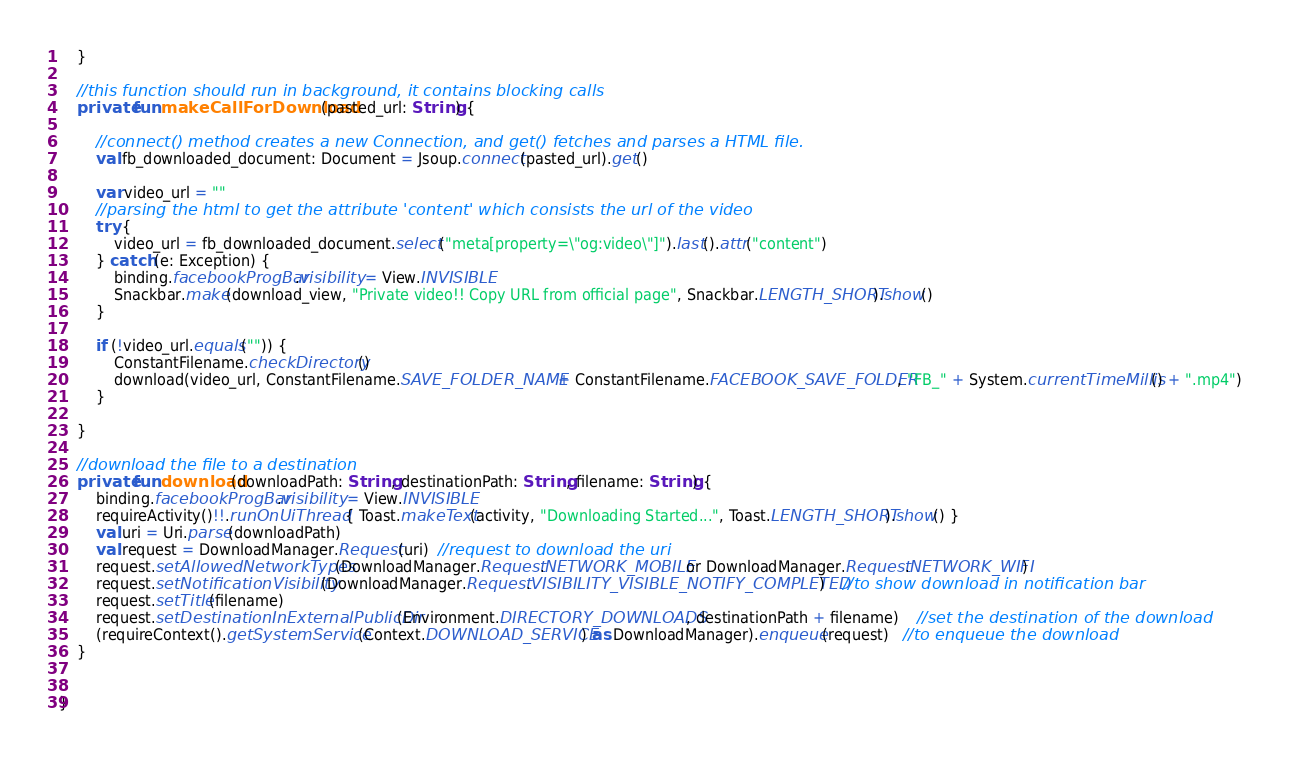Convert code to text. <code><loc_0><loc_0><loc_500><loc_500><_Kotlin_>    }

    //this function should run in background, it contains blocking calls
    private fun makeCallForDownload(pasted_url: String) {

        //connect() method creates a new Connection, and get() fetches and parses a HTML file.
        val fb_downloaded_document: Document = Jsoup.connect(pasted_url).get()

        var video_url = ""
        //parsing the html to get the attribute 'content' which consists the url of the video
        try {
            video_url = fb_downloaded_document.select("meta[property=\"og:video\"]").last().attr("content")
        } catch (e: Exception) {
            binding.facebookProgBar.visibility = View.INVISIBLE
            Snackbar.make(download_view, "Private video!! Copy URL from official page", Snackbar.LENGTH_SHORT).show()
        }

        if (!video_url.equals("")) {
            ConstantFilename.checkDirectory()
            download(video_url, ConstantFilename.SAVE_FOLDER_NAME + ConstantFilename.FACEBOOK_SAVE_FOLDER, "FB_" + System.currentTimeMillis() + ".mp4")
        }

    }

    //download the file to a destination
    private fun download(downloadPath: String, destinationPath: String, filename: String) {
        binding.facebookProgBar.visibility = View.INVISIBLE
        requireActivity()!!.runOnUiThread { Toast.makeText(activity, "Downloading Started...", Toast.LENGTH_SHORT).show() }
        val uri = Uri.parse(downloadPath)
        val request = DownloadManager.Request(uri)  //request to download the uri
        request.setAllowedNetworkTypes(DownloadManager.Request.NETWORK_MOBILE or DownloadManager.Request.NETWORK_WIFI)
        request.setNotificationVisibility(DownloadManager.Request.VISIBILITY_VISIBLE_NOTIFY_COMPLETED)    //to show download in notification bar
        request.setTitle(filename)
        request.setDestinationInExternalPublicDir(Environment.DIRECTORY_DOWNLOADS, destinationPath + filename)    //set the destination of the download
        (requireContext().getSystemService(Context.DOWNLOAD_SERVICE) as DownloadManager).enqueue(request)   //to enqueue the download
    }


}</code> 